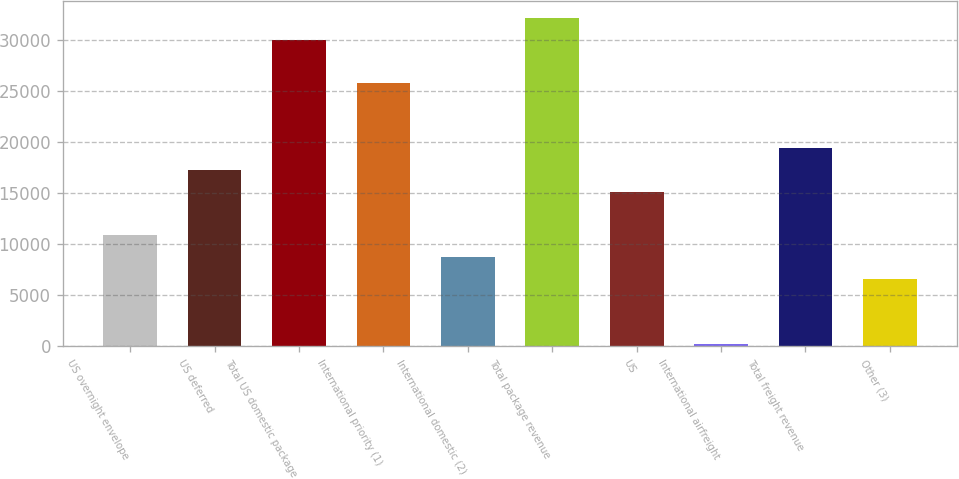Convert chart. <chart><loc_0><loc_0><loc_500><loc_500><bar_chart><fcel>US overnight envelope<fcel>US deferred<fcel>Total US domestic package<fcel>International priority (1)<fcel>International domestic (2)<fcel>Total package revenue<fcel>US<fcel>International airfreight<fcel>Total freight revenue<fcel>Other (3)<nl><fcel>10903<fcel>17294.2<fcel>30076.6<fcel>25815.8<fcel>8772.6<fcel>32207<fcel>15163.8<fcel>251<fcel>19424.6<fcel>6642.2<nl></chart> 